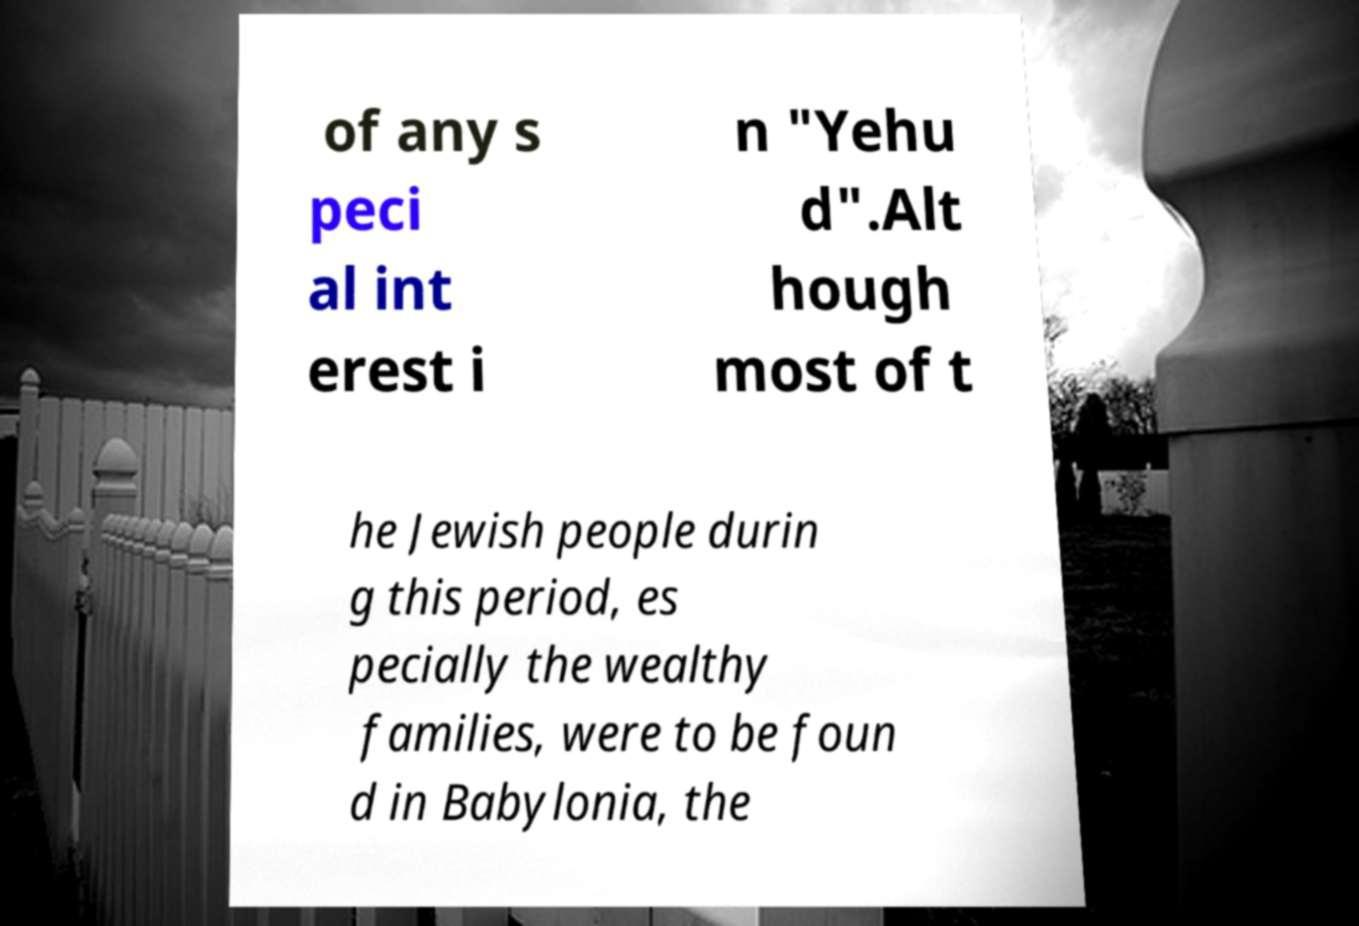Could you extract and type out the text from this image? of any s peci al int erest i n "Yehu d".Alt hough most of t he Jewish people durin g this period, es pecially the wealthy families, were to be foun d in Babylonia, the 